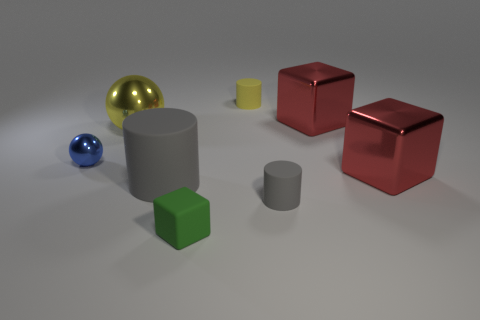Subtract all big shiny blocks. How many blocks are left? 1 Add 1 big gray rubber blocks. How many objects exist? 9 Subtract all yellow cylinders. How many cylinders are left? 2 Subtract all cylinders. How many objects are left? 5 Subtract 3 cubes. How many cubes are left? 0 Subtract all purple cylinders. How many green cubes are left? 1 Subtract all tiny cyan metal balls. Subtract all tiny rubber cylinders. How many objects are left? 6 Add 7 large yellow spheres. How many large yellow spheres are left? 8 Add 8 blue objects. How many blue objects exist? 9 Subtract 0 purple balls. How many objects are left? 8 